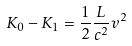<formula> <loc_0><loc_0><loc_500><loc_500>K _ { 0 } - K _ { 1 } = \frac { 1 } { 2 } \frac { L } { c ^ { 2 } } v ^ { 2 }</formula> 